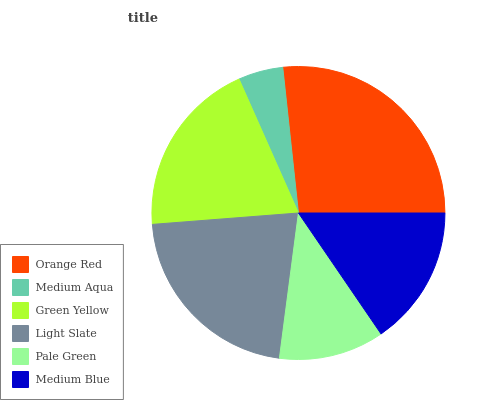Is Medium Aqua the minimum?
Answer yes or no. Yes. Is Orange Red the maximum?
Answer yes or no. Yes. Is Green Yellow the minimum?
Answer yes or no. No. Is Green Yellow the maximum?
Answer yes or no. No. Is Green Yellow greater than Medium Aqua?
Answer yes or no. Yes. Is Medium Aqua less than Green Yellow?
Answer yes or no. Yes. Is Medium Aqua greater than Green Yellow?
Answer yes or no. No. Is Green Yellow less than Medium Aqua?
Answer yes or no. No. Is Green Yellow the high median?
Answer yes or no. Yes. Is Medium Blue the low median?
Answer yes or no. Yes. Is Light Slate the high median?
Answer yes or no. No. Is Pale Green the low median?
Answer yes or no. No. 